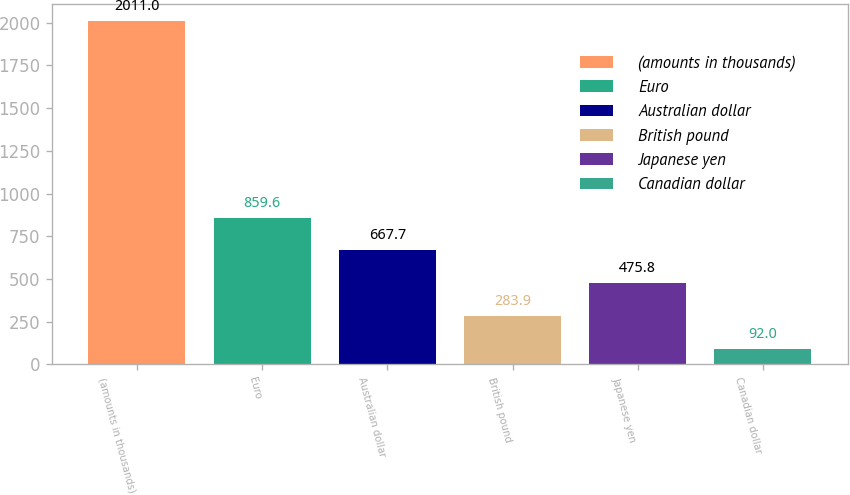Convert chart. <chart><loc_0><loc_0><loc_500><loc_500><bar_chart><fcel>(amounts in thousands)<fcel>Euro<fcel>Australian dollar<fcel>British pound<fcel>Japanese yen<fcel>Canadian dollar<nl><fcel>2011<fcel>859.6<fcel>667.7<fcel>283.9<fcel>475.8<fcel>92<nl></chart> 